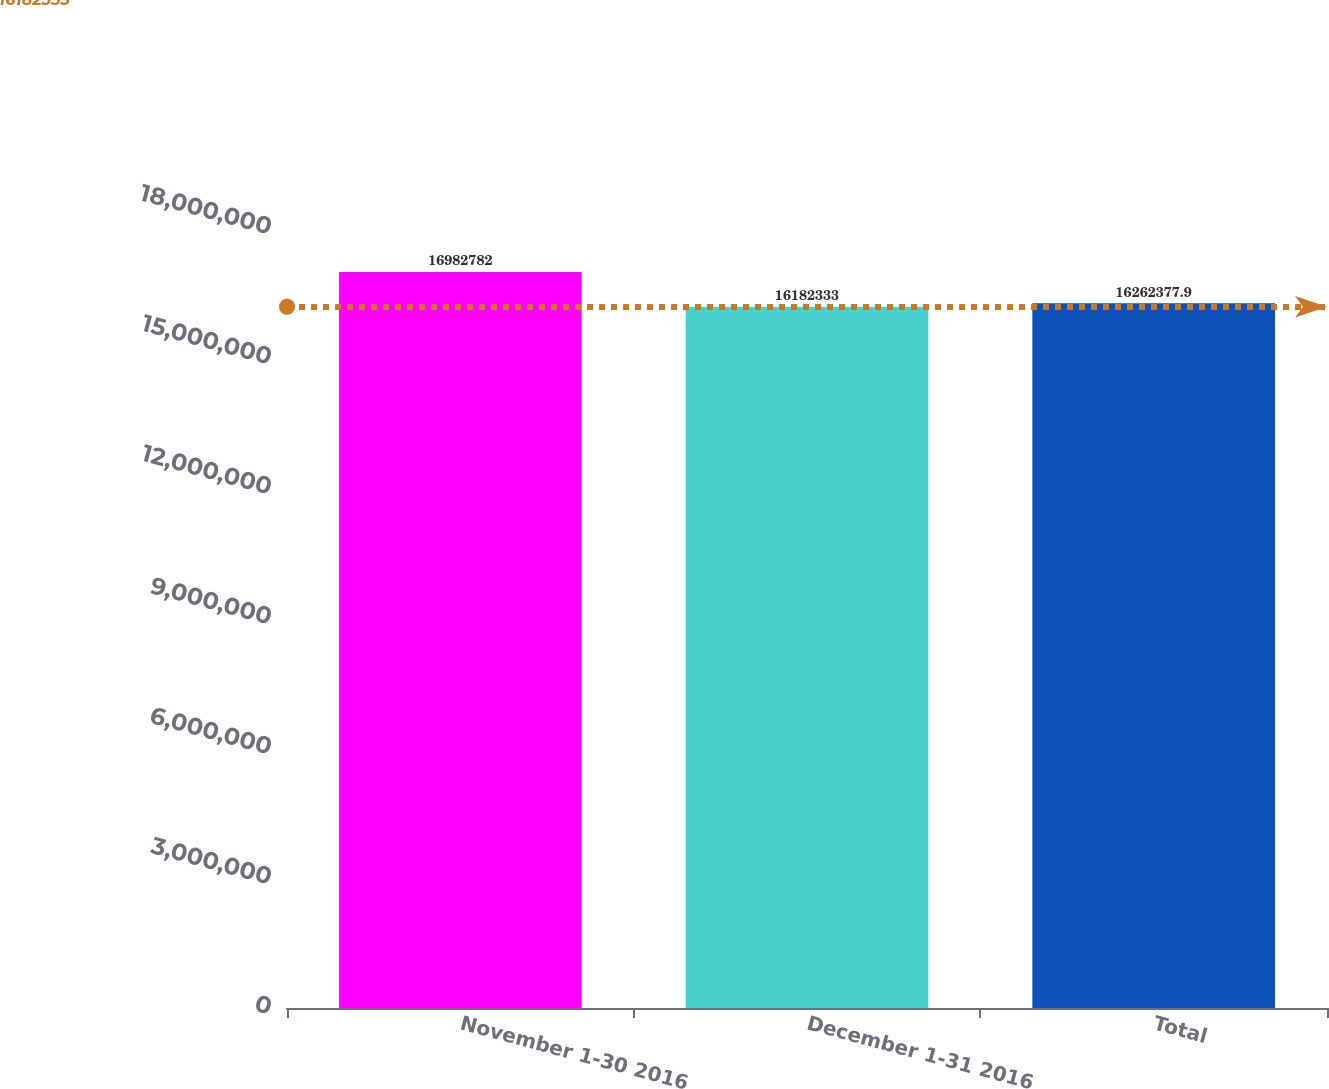Convert chart. <chart><loc_0><loc_0><loc_500><loc_500><bar_chart><fcel>November 1-30 2016<fcel>December 1-31 2016<fcel>Total<nl><fcel>1.69828e+07<fcel>1.61823e+07<fcel>1.62624e+07<nl></chart> 